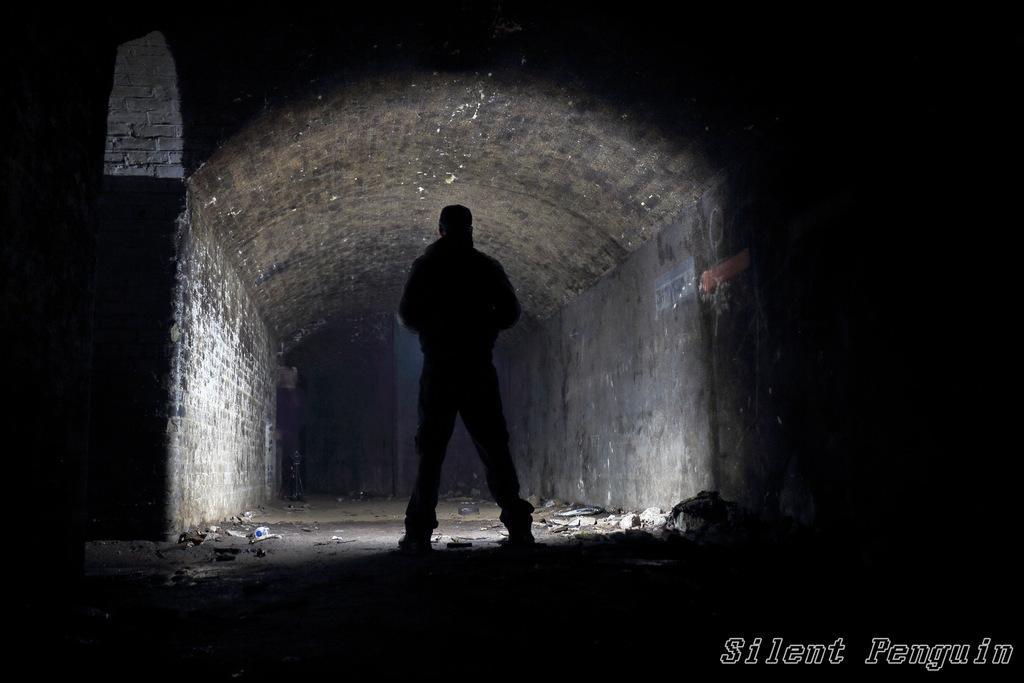In one or two sentences, can you explain what this image depicts? In this image, we can see a person standing in between walls. 